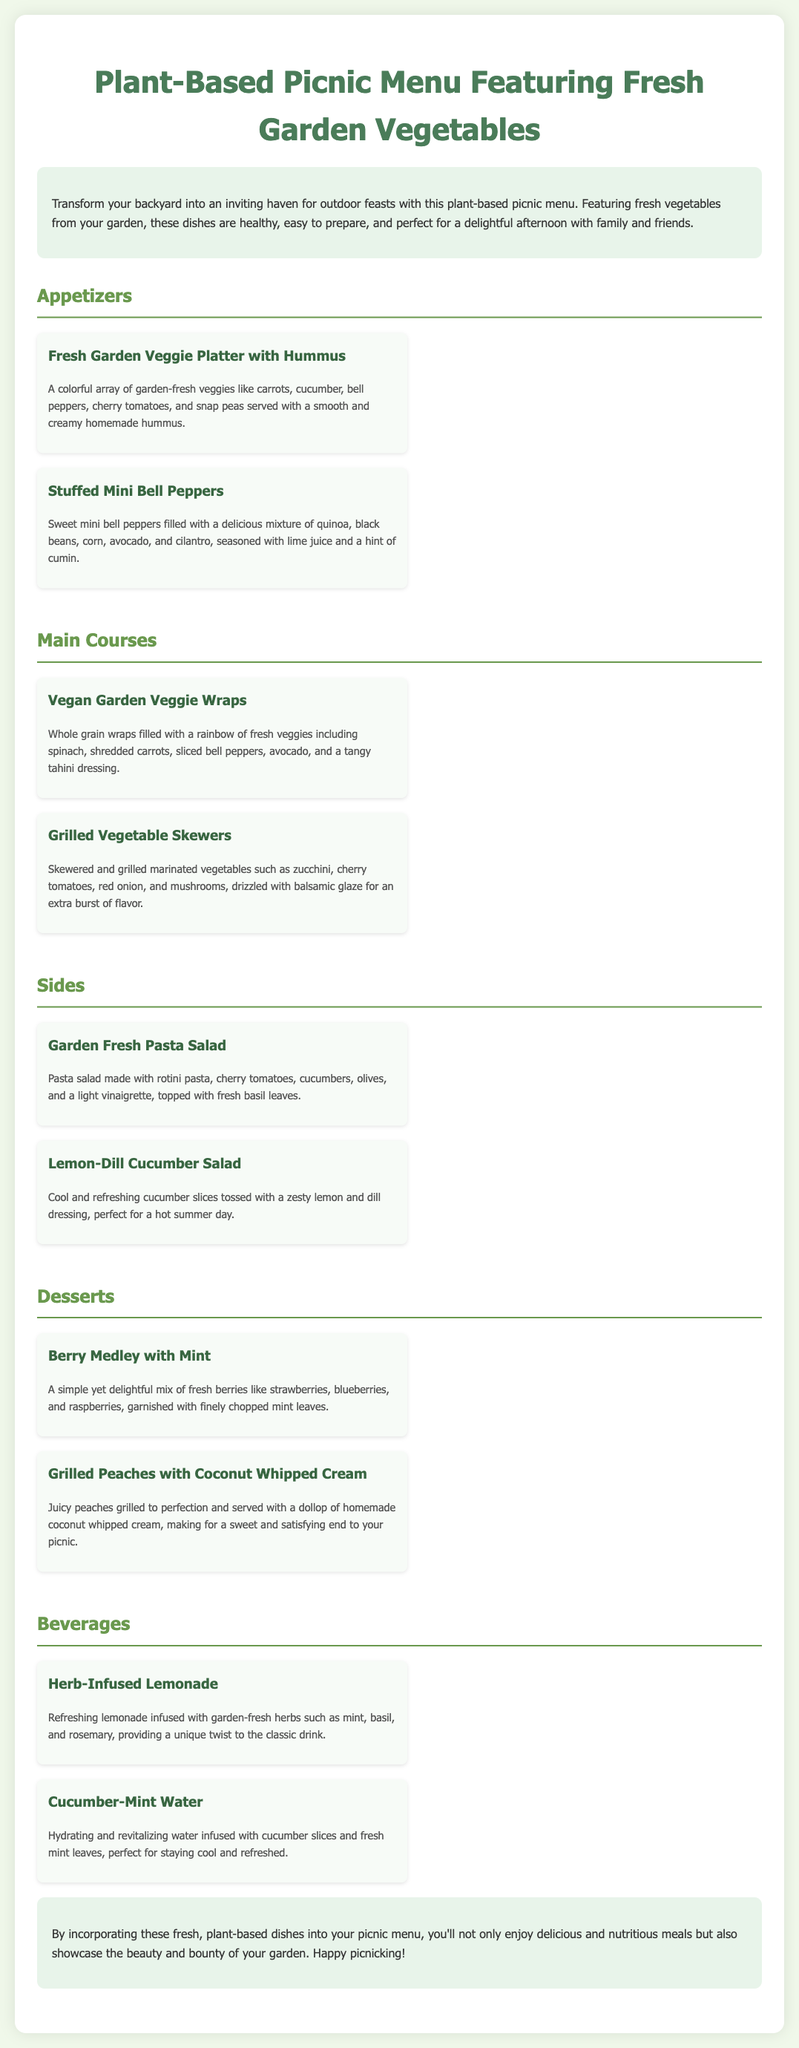What is the title of the document? The title is located at the top of the document and indicates the main topic being discussed.
Answer: Plant-Based Picnic Menu Featuring Fresh Garden Vegetables What is one of the appetizers mentioned in the menu? The appetizers section lists two specific dishes that are served at the picnic.
Answer: Fresh Garden Veggie Platter with Hummus How many main courses are included in the menu? The main courses section contains a specific number of dishes that fall under this category.
Answer: 2 What are the ingredients for the Stuffed Mini Bell Peppers? The ingredients for each dish are detailed in the description of the meal item in the document.
Answer: Quinoa, black beans, corn, avocado, cilantro Which dessert features grilled fruit? The desserts section describes dishes and their preparation methods, indicating the specific type of dessert in question.
Answer: Grilled Peaches with Coconut Whipped Cream What type of salad is mentioned as a side? The side dishes section includes various salad types, each with a brief description.
Answer: Lemon-Dill Cucumber Salad What is the refreshing beverage made with herbs? The beverages section mentions drinks prepared with specific ingredients and flavors that give them their unique characteristics.
Answer: Herb-Infused Lemonade Which meal item is served with a creamy dip? The description in the appetizers section identifies one dish that includes a dip for serving.
Answer: Fresh Garden Veggie Platter with Hummus 